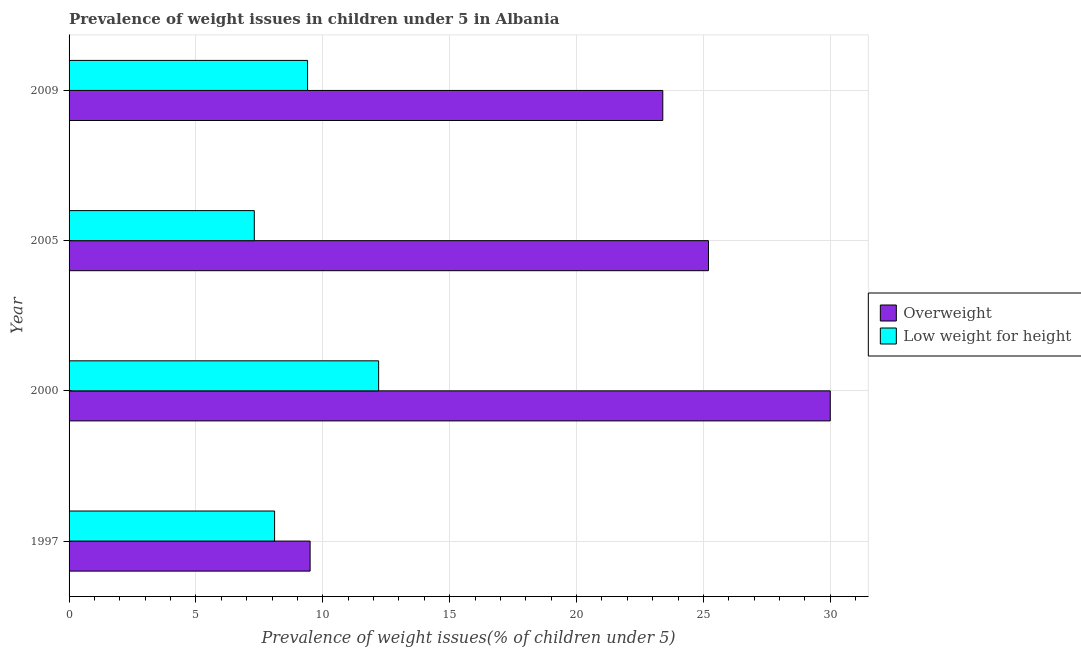Are the number of bars per tick equal to the number of legend labels?
Provide a short and direct response. Yes. Are the number of bars on each tick of the Y-axis equal?
Your answer should be very brief. Yes. How many bars are there on the 2nd tick from the bottom?
Your answer should be compact. 2. What is the percentage of overweight children in 1997?
Offer a very short reply. 9.5. Across all years, what is the maximum percentage of underweight children?
Offer a very short reply. 12.2. Across all years, what is the minimum percentage of underweight children?
Your response must be concise. 7.3. In which year was the percentage of overweight children minimum?
Your answer should be very brief. 1997. What is the total percentage of underweight children in the graph?
Your answer should be compact. 37. What is the difference between the percentage of overweight children in 1997 and that in 2009?
Offer a very short reply. -13.9. What is the difference between the percentage of underweight children in 2005 and the percentage of overweight children in 1997?
Provide a short and direct response. -2.2. What is the average percentage of overweight children per year?
Make the answer very short. 22.02. What is the ratio of the percentage of underweight children in 2005 to that in 2009?
Your response must be concise. 0.78. Is the percentage of overweight children in 1997 less than that in 2000?
Your response must be concise. Yes. Is the difference between the percentage of underweight children in 2005 and 2009 greater than the difference between the percentage of overweight children in 2005 and 2009?
Make the answer very short. No. What is the difference between the highest and the lowest percentage of overweight children?
Make the answer very short. 20.5. In how many years, is the percentage of underweight children greater than the average percentage of underweight children taken over all years?
Your answer should be very brief. 2. Is the sum of the percentage of underweight children in 1997 and 2005 greater than the maximum percentage of overweight children across all years?
Offer a very short reply. No. What does the 2nd bar from the top in 2009 represents?
Your answer should be very brief. Overweight. What does the 2nd bar from the bottom in 2005 represents?
Provide a succinct answer. Low weight for height. What is the difference between two consecutive major ticks on the X-axis?
Your answer should be very brief. 5. Are the values on the major ticks of X-axis written in scientific E-notation?
Give a very brief answer. No. Does the graph contain any zero values?
Ensure brevity in your answer.  No. Does the graph contain grids?
Ensure brevity in your answer.  Yes. Where does the legend appear in the graph?
Provide a succinct answer. Center right. What is the title of the graph?
Make the answer very short. Prevalence of weight issues in children under 5 in Albania. What is the label or title of the X-axis?
Keep it short and to the point. Prevalence of weight issues(% of children under 5). What is the Prevalence of weight issues(% of children under 5) in Overweight in 1997?
Offer a very short reply. 9.5. What is the Prevalence of weight issues(% of children under 5) of Low weight for height in 1997?
Your response must be concise. 8.1. What is the Prevalence of weight issues(% of children under 5) of Overweight in 2000?
Keep it short and to the point. 30. What is the Prevalence of weight issues(% of children under 5) of Low weight for height in 2000?
Give a very brief answer. 12.2. What is the Prevalence of weight issues(% of children under 5) in Overweight in 2005?
Your answer should be very brief. 25.2. What is the Prevalence of weight issues(% of children under 5) in Low weight for height in 2005?
Provide a short and direct response. 7.3. What is the Prevalence of weight issues(% of children under 5) in Overweight in 2009?
Provide a succinct answer. 23.4. What is the Prevalence of weight issues(% of children under 5) in Low weight for height in 2009?
Offer a terse response. 9.4. Across all years, what is the maximum Prevalence of weight issues(% of children under 5) in Overweight?
Your answer should be compact. 30. Across all years, what is the maximum Prevalence of weight issues(% of children under 5) in Low weight for height?
Give a very brief answer. 12.2. Across all years, what is the minimum Prevalence of weight issues(% of children under 5) in Overweight?
Your answer should be very brief. 9.5. Across all years, what is the minimum Prevalence of weight issues(% of children under 5) in Low weight for height?
Offer a terse response. 7.3. What is the total Prevalence of weight issues(% of children under 5) in Overweight in the graph?
Your response must be concise. 88.1. What is the total Prevalence of weight issues(% of children under 5) in Low weight for height in the graph?
Give a very brief answer. 37. What is the difference between the Prevalence of weight issues(% of children under 5) in Overweight in 1997 and that in 2000?
Ensure brevity in your answer.  -20.5. What is the difference between the Prevalence of weight issues(% of children under 5) in Overweight in 1997 and that in 2005?
Your answer should be compact. -15.7. What is the difference between the Prevalence of weight issues(% of children under 5) of Overweight in 2000 and that in 2005?
Your answer should be very brief. 4.8. What is the difference between the Prevalence of weight issues(% of children under 5) in Low weight for height in 2000 and that in 2005?
Give a very brief answer. 4.9. What is the difference between the Prevalence of weight issues(% of children under 5) of Overweight in 2000 and that in 2009?
Offer a terse response. 6.6. What is the difference between the Prevalence of weight issues(% of children under 5) of Low weight for height in 2000 and that in 2009?
Make the answer very short. 2.8. What is the difference between the Prevalence of weight issues(% of children under 5) of Low weight for height in 2005 and that in 2009?
Offer a terse response. -2.1. What is the difference between the Prevalence of weight issues(% of children under 5) in Overweight in 1997 and the Prevalence of weight issues(% of children under 5) in Low weight for height in 2005?
Make the answer very short. 2.2. What is the difference between the Prevalence of weight issues(% of children under 5) of Overweight in 2000 and the Prevalence of weight issues(% of children under 5) of Low weight for height in 2005?
Ensure brevity in your answer.  22.7. What is the difference between the Prevalence of weight issues(% of children under 5) in Overweight in 2000 and the Prevalence of weight issues(% of children under 5) in Low weight for height in 2009?
Ensure brevity in your answer.  20.6. What is the average Prevalence of weight issues(% of children under 5) in Overweight per year?
Provide a succinct answer. 22.02. What is the average Prevalence of weight issues(% of children under 5) of Low weight for height per year?
Your response must be concise. 9.25. In the year 2009, what is the difference between the Prevalence of weight issues(% of children under 5) in Overweight and Prevalence of weight issues(% of children under 5) in Low weight for height?
Keep it short and to the point. 14. What is the ratio of the Prevalence of weight issues(% of children under 5) of Overweight in 1997 to that in 2000?
Your answer should be very brief. 0.32. What is the ratio of the Prevalence of weight issues(% of children under 5) of Low weight for height in 1997 to that in 2000?
Offer a very short reply. 0.66. What is the ratio of the Prevalence of weight issues(% of children under 5) of Overweight in 1997 to that in 2005?
Offer a very short reply. 0.38. What is the ratio of the Prevalence of weight issues(% of children under 5) of Low weight for height in 1997 to that in 2005?
Your response must be concise. 1.11. What is the ratio of the Prevalence of weight issues(% of children under 5) of Overweight in 1997 to that in 2009?
Your answer should be compact. 0.41. What is the ratio of the Prevalence of weight issues(% of children under 5) of Low weight for height in 1997 to that in 2009?
Your response must be concise. 0.86. What is the ratio of the Prevalence of weight issues(% of children under 5) in Overweight in 2000 to that in 2005?
Give a very brief answer. 1.19. What is the ratio of the Prevalence of weight issues(% of children under 5) of Low weight for height in 2000 to that in 2005?
Provide a short and direct response. 1.67. What is the ratio of the Prevalence of weight issues(% of children under 5) of Overweight in 2000 to that in 2009?
Make the answer very short. 1.28. What is the ratio of the Prevalence of weight issues(% of children under 5) of Low weight for height in 2000 to that in 2009?
Your answer should be very brief. 1.3. What is the ratio of the Prevalence of weight issues(% of children under 5) of Low weight for height in 2005 to that in 2009?
Offer a very short reply. 0.78. What is the difference between the highest and the second highest Prevalence of weight issues(% of children under 5) in Low weight for height?
Offer a terse response. 2.8. What is the difference between the highest and the lowest Prevalence of weight issues(% of children under 5) of Overweight?
Offer a terse response. 20.5. 